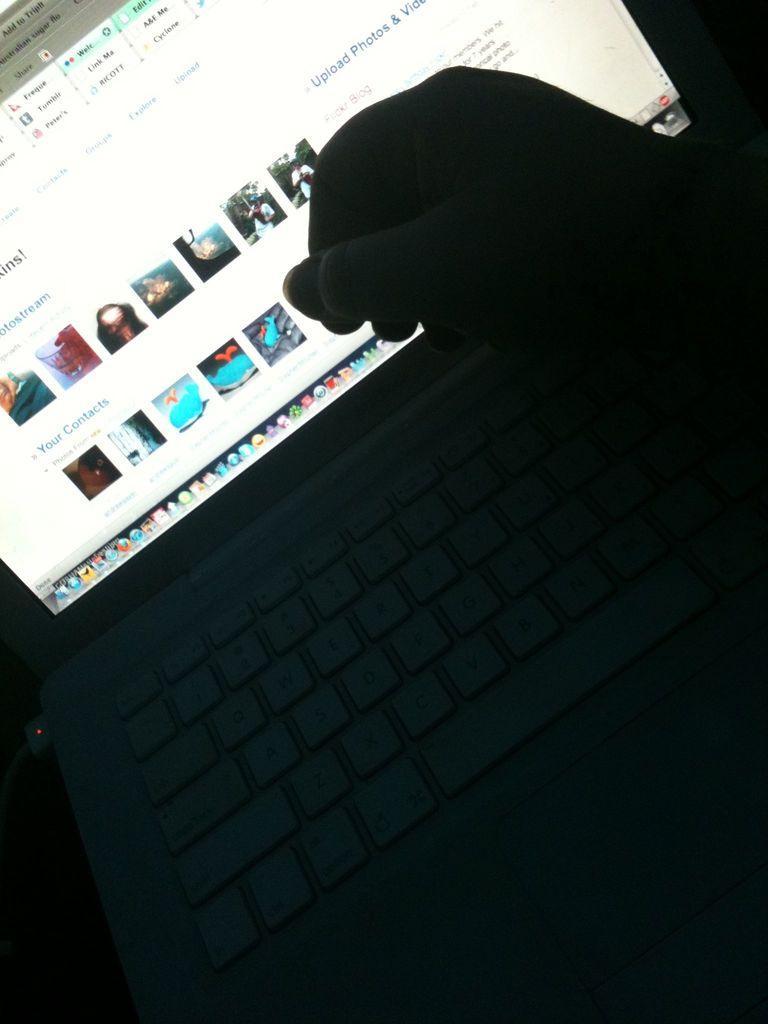Can you describe this image briefly? In this picture I can see there is a laptop, it has a screen and there are few images and some information on the screen and a person is placing his hand at right and is holding a object. The laptop is connected with a cable. 